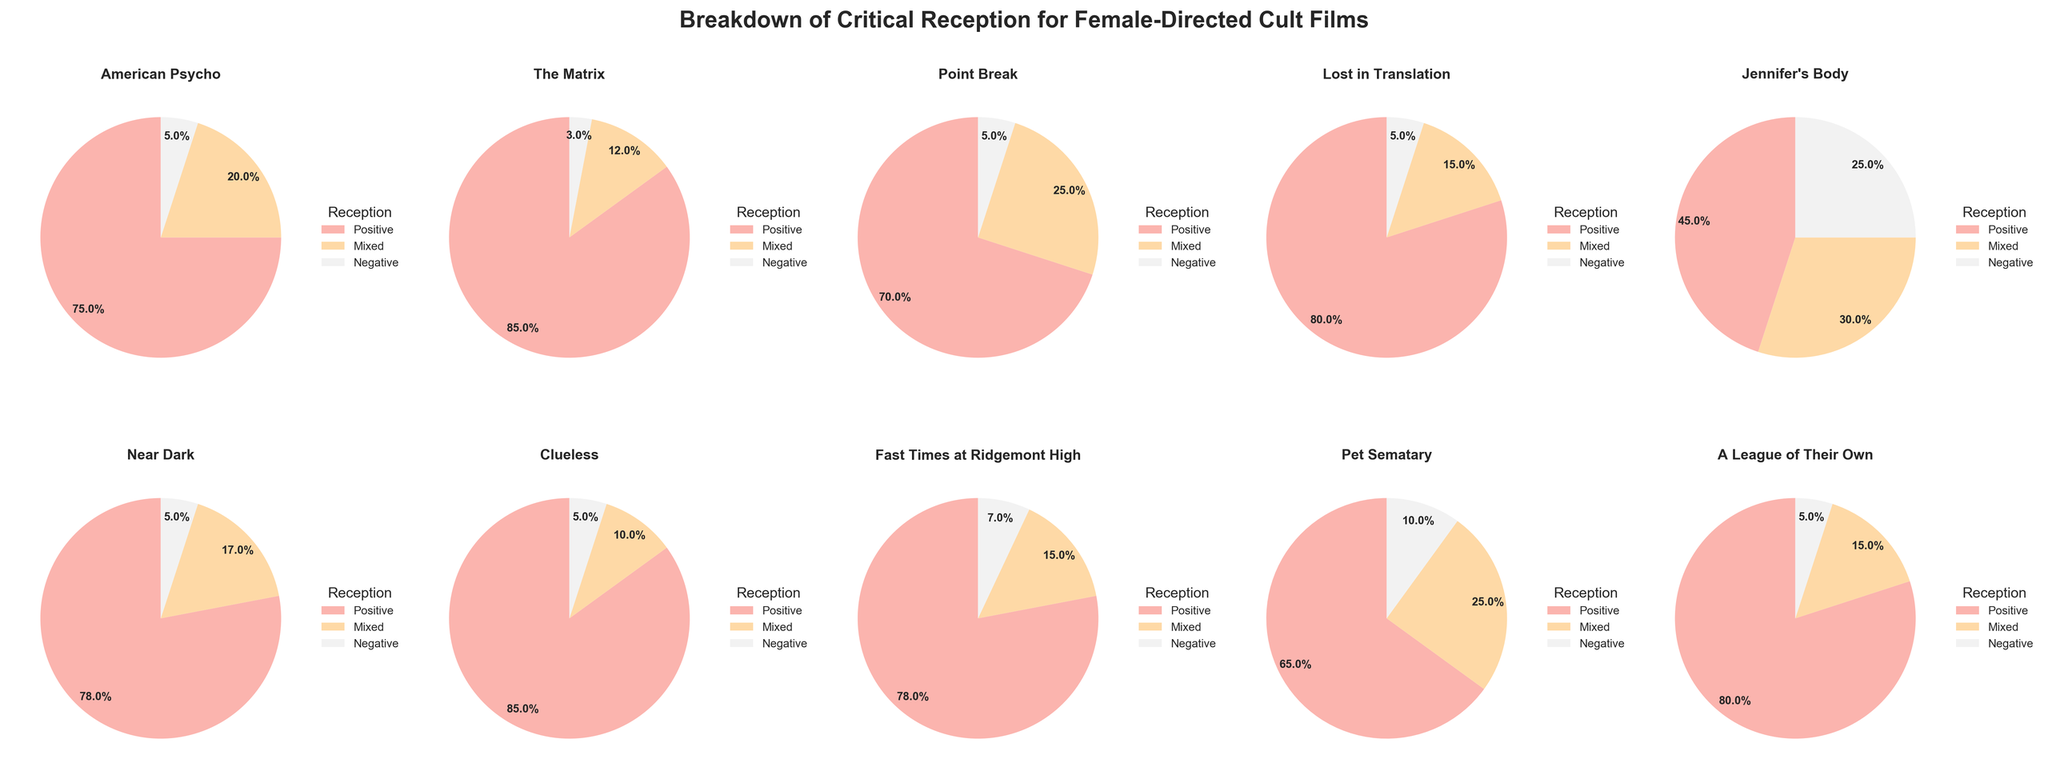What is the title of the figure? The title of the figure is prominently displayed at the top of the subplot, indicating the subject matter of the visual representation.
Answer: Breakdown of Critical Reception for Female-Directed Cult Films How many films are represented in the figure? By counting the pie charts present in the subplot, we can determine the total number of films represented in the visual. There is one pie chart for each film, arranged in a grid pattern.
Answer: 10 Which film has the highest percentage of positive reviews? To determine this, we need to examine each pie chart and identify the film with the largest segment corresponding to positive reviews. The percentage is labeled on each segment.
Answer: The Matrix How do the percentages of mixed reviews for 'Fast Times at Ridgemont High' compare to 'Near Dark'? By looking at the pie charts for both 'Fast Times at Ridgemont High' and 'Near Dark', we can spot the segments labeled 'Mixed' and compare their respective percentages.
Answer: 15% for Fast Times at Ridgemont High and 17% for Near Dark What is the combined percentage of positive and mixed reviews for 'Jennifer's Body'? First, identify the percentages for both the positive and mixed segments in the pie chart for 'Jennifer's Body', then add them together. Positive is 45% and Mixed is 30%. 45 + 30 = 75
Answer: 75% Which film among those listed has the highest percentage of negative reviews? Examine each pie chart to identify the segment labeled with the highest percentage of 'Negative' reviews. The percentages are marked on each segment.
Answer: Jennifer's Body Compare the percentage of positive reviews for 'American Psycho' and 'Clueless'. Which is higher and by how much? Check the pie charts for both 'American Psycho' and 'Clueless', note the positive review percentages, and calculate the difference. American Psycho has 75%, Clueless has 85%, so 85 - 75 = 10
Answer: Clueless by 10% What proportion of films have 80% or more positive reviews? Count the number of films with positive review segments labeled with 80% or higher from the visual representation. These films are 'The Matrix', 'Clueless', 'Lost in Translation', and 'A League of Their Own'. 4 out of 10 films fits the criteria.
Answer: 40% Which film has the largest difference between positive and negative reviews? For each film, subtract the percentage of negative reviews from the positive reviews, and identify the film with the largest resulting value.
Answer: The Matrix (85% - 3% = 82%) What is the average percentage of mixed reviews across all films? Sum the percentages of 'Mixed' reviews for each film and divide by the total number of films (10). The sums are: 20, 12, 25, 15, 30, 17, 10, 15, 25, 15. Average = (20 + 12 + 25 + 15 + 30 + 17 + 10 + 15 + 25 + 15) / 10 = 18.4
Answer: 18.4% 